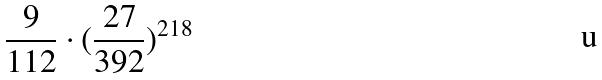<formula> <loc_0><loc_0><loc_500><loc_500>\frac { 9 } { 1 1 2 } \cdot ( \frac { 2 7 } { 3 9 2 } ) ^ { 2 1 8 }</formula> 